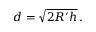<formula> <loc_0><loc_0><loc_500><loc_500>d = { \sqrt { 2 R ^ { \prime } h } } \, .</formula> 